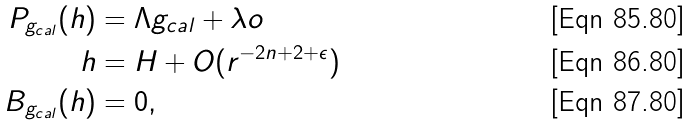<formula> <loc_0><loc_0><loc_500><loc_500>P _ { g _ { c a l } } ( h ) & = \Lambda { g _ { c a l } } + \lambda o \\ h & = H + O ( r ^ { - 2 n + 2 + \epsilon } ) \\ B _ { g _ { c a l } } ( h ) & = 0 ,</formula> 